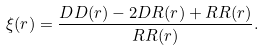Convert formula to latex. <formula><loc_0><loc_0><loc_500><loc_500>\xi ( r ) = \frac { D D ( r ) - 2 D R ( r ) + R R ( r ) } { R R ( r ) } .</formula> 